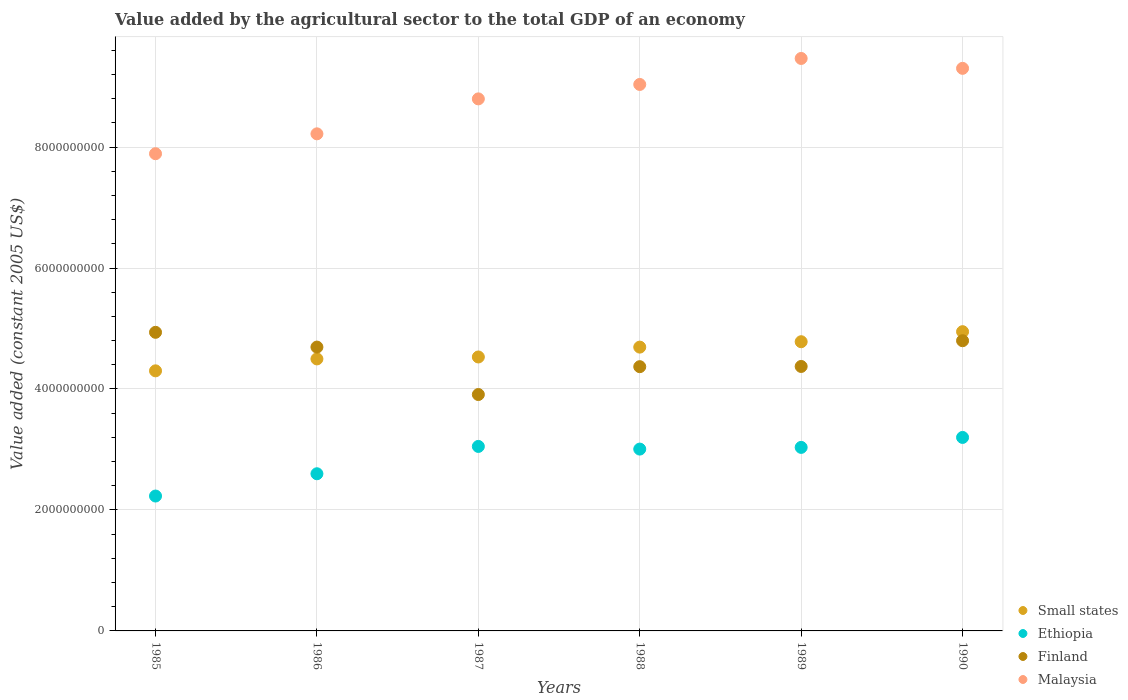How many different coloured dotlines are there?
Provide a succinct answer. 4. What is the value added by the agricultural sector in Finland in 1990?
Keep it short and to the point. 4.80e+09. Across all years, what is the maximum value added by the agricultural sector in Malaysia?
Provide a short and direct response. 9.46e+09. Across all years, what is the minimum value added by the agricultural sector in Finland?
Your answer should be very brief. 3.91e+09. In which year was the value added by the agricultural sector in Ethiopia minimum?
Offer a terse response. 1985. What is the total value added by the agricultural sector in Malaysia in the graph?
Provide a succinct answer. 5.27e+1. What is the difference between the value added by the agricultural sector in Finland in 1986 and that in 1990?
Ensure brevity in your answer.  -1.05e+08. What is the difference between the value added by the agricultural sector in Malaysia in 1986 and the value added by the agricultural sector in Small states in 1987?
Make the answer very short. 3.69e+09. What is the average value added by the agricultural sector in Malaysia per year?
Your response must be concise. 8.78e+09. In the year 1985, what is the difference between the value added by the agricultural sector in Finland and value added by the agricultural sector in Small states?
Ensure brevity in your answer.  6.37e+08. In how many years, is the value added by the agricultural sector in Malaysia greater than 800000000 US$?
Provide a succinct answer. 6. What is the ratio of the value added by the agricultural sector in Small states in 1987 to that in 1989?
Make the answer very short. 0.95. Is the difference between the value added by the agricultural sector in Finland in 1987 and 1988 greater than the difference between the value added by the agricultural sector in Small states in 1987 and 1988?
Your answer should be compact. No. What is the difference between the highest and the second highest value added by the agricultural sector in Malaysia?
Offer a terse response. 1.64e+08. What is the difference between the highest and the lowest value added by the agricultural sector in Malaysia?
Your answer should be compact. 1.57e+09. In how many years, is the value added by the agricultural sector in Finland greater than the average value added by the agricultural sector in Finland taken over all years?
Provide a succinct answer. 3. Is it the case that in every year, the sum of the value added by the agricultural sector in Small states and value added by the agricultural sector in Malaysia  is greater than the sum of value added by the agricultural sector in Finland and value added by the agricultural sector in Ethiopia?
Make the answer very short. Yes. How many years are there in the graph?
Provide a short and direct response. 6. Does the graph contain grids?
Offer a terse response. Yes. What is the title of the graph?
Your response must be concise. Value added by the agricultural sector to the total GDP of an economy. What is the label or title of the Y-axis?
Provide a short and direct response. Value added (constant 2005 US$). What is the Value added (constant 2005 US$) of Small states in 1985?
Provide a succinct answer. 4.30e+09. What is the Value added (constant 2005 US$) in Ethiopia in 1985?
Your answer should be compact. 2.23e+09. What is the Value added (constant 2005 US$) of Finland in 1985?
Ensure brevity in your answer.  4.94e+09. What is the Value added (constant 2005 US$) of Malaysia in 1985?
Offer a very short reply. 7.89e+09. What is the Value added (constant 2005 US$) of Small states in 1986?
Provide a short and direct response. 4.50e+09. What is the Value added (constant 2005 US$) in Ethiopia in 1986?
Your answer should be compact. 2.60e+09. What is the Value added (constant 2005 US$) of Finland in 1986?
Provide a short and direct response. 4.69e+09. What is the Value added (constant 2005 US$) in Malaysia in 1986?
Ensure brevity in your answer.  8.22e+09. What is the Value added (constant 2005 US$) in Small states in 1987?
Ensure brevity in your answer.  4.53e+09. What is the Value added (constant 2005 US$) in Ethiopia in 1987?
Offer a very short reply. 3.05e+09. What is the Value added (constant 2005 US$) in Finland in 1987?
Give a very brief answer. 3.91e+09. What is the Value added (constant 2005 US$) of Malaysia in 1987?
Ensure brevity in your answer.  8.80e+09. What is the Value added (constant 2005 US$) in Small states in 1988?
Keep it short and to the point. 4.69e+09. What is the Value added (constant 2005 US$) in Ethiopia in 1988?
Offer a terse response. 3.01e+09. What is the Value added (constant 2005 US$) in Finland in 1988?
Make the answer very short. 4.37e+09. What is the Value added (constant 2005 US$) of Malaysia in 1988?
Provide a succinct answer. 9.03e+09. What is the Value added (constant 2005 US$) of Small states in 1989?
Provide a short and direct response. 4.78e+09. What is the Value added (constant 2005 US$) in Ethiopia in 1989?
Your response must be concise. 3.03e+09. What is the Value added (constant 2005 US$) of Finland in 1989?
Your response must be concise. 4.37e+09. What is the Value added (constant 2005 US$) in Malaysia in 1989?
Provide a succinct answer. 9.46e+09. What is the Value added (constant 2005 US$) in Small states in 1990?
Make the answer very short. 4.95e+09. What is the Value added (constant 2005 US$) of Ethiopia in 1990?
Your answer should be very brief. 3.20e+09. What is the Value added (constant 2005 US$) in Finland in 1990?
Offer a very short reply. 4.80e+09. What is the Value added (constant 2005 US$) in Malaysia in 1990?
Give a very brief answer. 9.30e+09. Across all years, what is the maximum Value added (constant 2005 US$) of Small states?
Provide a short and direct response. 4.95e+09. Across all years, what is the maximum Value added (constant 2005 US$) in Ethiopia?
Make the answer very short. 3.20e+09. Across all years, what is the maximum Value added (constant 2005 US$) of Finland?
Your response must be concise. 4.94e+09. Across all years, what is the maximum Value added (constant 2005 US$) of Malaysia?
Offer a very short reply. 9.46e+09. Across all years, what is the minimum Value added (constant 2005 US$) in Small states?
Provide a succinct answer. 4.30e+09. Across all years, what is the minimum Value added (constant 2005 US$) in Ethiopia?
Offer a terse response. 2.23e+09. Across all years, what is the minimum Value added (constant 2005 US$) of Finland?
Ensure brevity in your answer.  3.91e+09. Across all years, what is the minimum Value added (constant 2005 US$) in Malaysia?
Your answer should be very brief. 7.89e+09. What is the total Value added (constant 2005 US$) of Small states in the graph?
Offer a very short reply. 2.77e+1. What is the total Value added (constant 2005 US$) of Ethiopia in the graph?
Keep it short and to the point. 1.71e+1. What is the total Value added (constant 2005 US$) of Finland in the graph?
Offer a very short reply. 2.71e+1. What is the total Value added (constant 2005 US$) of Malaysia in the graph?
Your response must be concise. 5.27e+1. What is the difference between the Value added (constant 2005 US$) in Small states in 1985 and that in 1986?
Give a very brief answer. -1.97e+08. What is the difference between the Value added (constant 2005 US$) in Ethiopia in 1985 and that in 1986?
Provide a succinct answer. -3.68e+08. What is the difference between the Value added (constant 2005 US$) of Finland in 1985 and that in 1986?
Provide a short and direct response. 2.44e+08. What is the difference between the Value added (constant 2005 US$) in Malaysia in 1985 and that in 1986?
Provide a short and direct response. -3.29e+08. What is the difference between the Value added (constant 2005 US$) in Small states in 1985 and that in 1987?
Give a very brief answer. -2.29e+08. What is the difference between the Value added (constant 2005 US$) in Ethiopia in 1985 and that in 1987?
Ensure brevity in your answer.  -8.20e+08. What is the difference between the Value added (constant 2005 US$) in Finland in 1985 and that in 1987?
Your response must be concise. 1.03e+09. What is the difference between the Value added (constant 2005 US$) in Malaysia in 1985 and that in 1987?
Offer a very short reply. -9.07e+08. What is the difference between the Value added (constant 2005 US$) of Small states in 1985 and that in 1988?
Provide a succinct answer. -3.92e+08. What is the difference between the Value added (constant 2005 US$) of Ethiopia in 1985 and that in 1988?
Ensure brevity in your answer.  -7.76e+08. What is the difference between the Value added (constant 2005 US$) in Finland in 1985 and that in 1988?
Ensure brevity in your answer.  5.68e+08. What is the difference between the Value added (constant 2005 US$) of Malaysia in 1985 and that in 1988?
Your response must be concise. -1.15e+09. What is the difference between the Value added (constant 2005 US$) of Small states in 1985 and that in 1989?
Your answer should be compact. -4.81e+08. What is the difference between the Value added (constant 2005 US$) in Ethiopia in 1985 and that in 1989?
Make the answer very short. -8.04e+08. What is the difference between the Value added (constant 2005 US$) of Finland in 1985 and that in 1989?
Make the answer very short. 5.64e+08. What is the difference between the Value added (constant 2005 US$) of Malaysia in 1985 and that in 1989?
Ensure brevity in your answer.  -1.57e+09. What is the difference between the Value added (constant 2005 US$) in Small states in 1985 and that in 1990?
Give a very brief answer. -6.48e+08. What is the difference between the Value added (constant 2005 US$) in Ethiopia in 1985 and that in 1990?
Keep it short and to the point. -9.69e+08. What is the difference between the Value added (constant 2005 US$) in Finland in 1985 and that in 1990?
Your response must be concise. 1.39e+08. What is the difference between the Value added (constant 2005 US$) of Malaysia in 1985 and that in 1990?
Your answer should be compact. -1.41e+09. What is the difference between the Value added (constant 2005 US$) in Small states in 1986 and that in 1987?
Offer a terse response. -3.21e+07. What is the difference between the Value added (constant 2005 US$) in Ethiopia in 1986 and that in 1987?
Offer a terse response. -4.52e+08. What is the difference between the Value added (constant 2005 US$) in Finland in 1986 and that in 1987?
Provide a succinct answer. 7.84e+08. What is the difference between the Value added (constant 2005 US$) of Malaysia in 1986 and that in 1987?
Provide a short and direct response. -5.78e+08. What is the difference between the Value added (constant 2005 US$) in Small states in 1986 and that in 1988?
Offer a terse response. -1.95e+08. What is the difference between the Value added (constant 2005 US$) in Ethiopia in 1986 and that in 1988?
Give a very brief answer. -4.08e+08. What is the difference between the Value added (constant 2005 US$) of Finland in 1986 and that in 1988?
Give a very brief answer. 3.24e+08. What is the difference between the Value added (constant 2005 US$) of Malaysia in 1986 and that in 1988?
Your response must be concise. -8.16e+08. What is the difference between the Value added (constant 2005 US$) of Small states in 1986 and that in 1989?
Keep it short and to the point. -2.84e+08. What is the difference between the Value added (constant 2005 US$) in Ethiopia in 1986 and that in 1989?
Provide a succinct answer. -4.36e+08. What is the difference between the Value added (constant 2005 US$) of Finland in 1986 and that in 1989?
Your answer should be compact. 3.20e+08. What is the difference between the Value added (constant 2005 US$) of Malaysia in 1986 and that in 1989?
Your response must be concise. -1.25e+09. What is the difference between the Value added (constant 2005 US$) in Small states in 1986 and that in 1990?
Your answer should be very brief. -4.51e+08. What is the difference between the Value added (constant 2005 US$) of Ethiopia in 1986 and that in 1990?
Offer a very short reply. -6.00e+08. What is the difference between the Value added (constant 2005 US$) in Finland in 1986 and that in 1990?
Offer a terse response. -1.05e+08. What is the difference between the Value added (constant 2005 US$) of Malaysia in 1986 and that in 1990?
Your response must be concise. -1.08e+09. What is the difference between the Value added (constant 2005 US$) in Small states in 1987 and that in 1988?
Provide a short and direct response. -1.63e+08. What is the difference between the Value added (constant 2005 US$) of Ethiopia in 1987 and that in 1988?
Your answer should be compact. 4.40e+07. What is the difference between the Value added (constant 2005 US$) of Finland in 1987 and that in 1988?
Give a very brief answer. -4.60e+08. What is the difference between the Value added (constant 2005 US$) of Malaysia in 1987 and that in 1988?
Ensure brevity in your answer.  -2.39e+08. What is the difference between the Value added (constant 2005 US$) of Small states in 1987 and that in 1989?
Provide a succinct answer. -2.52e+08. What is the difference between the Value added (constant 2005 US$) in Ethiopia in 1987 and that in 1989?
Keep it short and to the point. 1.59e+07. What is the difference between the Value added (constant 2005 US$) in Finland in 1987 and that in 1989?
Your answer should be very brief. -4.64e+08. What is the difference between the Value added (constant 2005 US$) in Malaysia in 1987 and that in 1989?
Offer a terse response. -6.68e+08. What is the difference between the Value added (constant 2005 US$) of Small states in 1987 and that in 1990?
Keep it short and to the point. -4.18e+08. What is the difference between the Value added (constant 2005 US$) of Ethiopia in 1987 and that in 1990?
Your answer should be compact. -1.49e+08. What is the difference between the Value added (constant 2005 US$) in Finland in 1987 and that in 1990?
Your answer should be compact. -8.89e+08. What is the difference between the Value added (constant 2005 US$) of Malaysia in 1987 and that in 1990?
Offer a terse response. -5.05e+08. What is the difference between the Value added (constant 2005 US$) of Small states in 1988 and that in 1989?
Your response must be concise. -8.93e+07. What is the difference between the Value added (constant 2005 US$) in Ethiopia in 1988 and that in 1989?
Make the answer very short. -2.81e+07. What is the difference between the Value added (constant 2005 US$) of Finland in 1988 and that in 1989?
Give a very brief answer. -3.63e+06. What is the difference between the Value added (constant 2005 US$) of Malaysia in 1988 and that in 1989?
Give a very brief answer. -4.30e+08. What is the difference between the Value added (constant 2005 US$) of Small states in 1988 and that in 1990?
Offer a very short reply. -2.55e+08. What is the difference between the Value added (constant 2005 US$) of Ethiopia in 1988 and that in 1990?
Keep it short and to the point. -1.93e+08. What is the difference between the Value added (constant 2005 US$) of Finland in 1988 and that in 1990?
Offer a terse response. -4.29e+08. What is the difference between the Value added (constant 2005 US$) of Malaysia in 1988 and that in 1990?
Keep it short and to the point. -2.66e+08. What is the difference between the Value added (constant 2005 US$) in Small states in 1989 and that in 1990?
Provide a succinct answer. -1.66e+08. What is the difference between the Value added (constant 2005 US$) in Ethiopia in 1989 and that in 1990?
Your response must be concise. -1.65e+08. What is the difference between the Value added (constant 2005 US$) of Finland in 1989 and that in 1990?
Ensure brevity in your answer.  -4.25e+08. What is the difference between the Value added (constant 2005 US$) in Malaysia in 1989 and that in 1990?
Ensure brevity in your answer.  1.64e+08. What is the difference between the Value added (constant 2005 US$) of Small states in 1985 and the Value added (constant 2005 US$) of Ethiopia in 1986?
Offer a very short reply. 1.70e+09. What is the difference between the Value added (constant 2005 US$) in Small states in 1985 and the Value added (constant 2005 US$) in Finland in 1986?
Ensure brevity in your answer.  -3.93e+08. What is the difference between the Value added (constant 2005 US$) in Small states in 1985 and the Value added (constant 2005 US$) in Malaysia in 1986?
Make the answer very short. -3.92e+09. What is the difference between the Value added (constant 2005 US$) in Ethiopia in 1985 and the Value added (constant 2005 US$) in Finland in 1986?
Your response must be concise. -2.46e+09. What is the difference between the Value added (constant 2005 US$) in Ethiopia in 1985 and the Value added (constant 2005 US$) in Malaysia in 1986?
Offer a very short reply. -5.99e+09. What is the difference between the Value added (constant 2005 US$) in Finland in 1985 and the Value added (constant 2005 US$) in Malaysia in 1986?
Your answer should be compact. -3.28e+09. What is the difference between the Value added (constant 2005 US$) in Small states in 1985 and the Value added (constant 2005 US$) in Ethiopia in 1987?
Provide a short and direct response. 1.25e+09. What is the difference between the Value added (constant 2005 US$) of Small states in 1985 and the Value added (constant 2005 US$) of Finland in 1987?
Give a very brief answer. 3.92e+08. What is the difference between the Value added (constant 2005 US$) of Small states in 1985 and the Value added (constant 2005 US$) of Malaysia in 1987?
Ensure brevity in your answer.  -4.50e+09. What is the difference between the Value added (constant 2005 US$) in Ethiopia in 1985 and the Value added (constant 2005 US$) in Finland in 1987?
Your answer should be very brief. -1.68e+09. What is the difference between the Value added (constant 2005 US$) of Ethiopia in 1985 and the Value added (constant 2005 US$) of Malaysia in 1987?
Keep it short and to the point. -6.57e+09. What is the difference between the Value added (constant 2005 US$) of Finland in 1985 and the Value added (constant 2005 US$) of Malaysia in 1987?
Provide a succinct answer. -3.86e+09. What is the difference between the Value added (constant 2005 US$) in Small states in 1985 and the Value added (constant 2005 US$) in Ethiopia in 1988?
Provide a short and direct response. 1.29e+09. What is the difference between the Value added (constant 2005 US$) in Small states in 1985 and the Value added (constant 2005 US$) in Finland in 1988?
Provide a succinct answer. -6.89e+07. What is the difference between the Value added (constant 2005 US$) of Small states in 1985 and the Value added (constant 2005 US$) of Malaysia in 1988?
Ensure brevity in your answer.  -4.73e+09. What is the difference between the Value added (constant 2005 US$) of Ethiopia in 1985 and the Value added (constant 2005 US$) of Finland in 1988?
Offer a very short reply. -2.14e+09. What is the difference between the Value added (constant 2005 US$) in Ethiopia in 1985 and the Value added (constant 2005 US$) in Malaysia in 1988?
Your answer should be very brief. -6.80e+09. What is the difference between the Value added (constant 2005 US$) in Finland in 1985 and the Value added (constant 2005 US$) in Malaysia in 1988?
Make the answer very short. -4.10e+09. What is the difference between the Value added (constant 2005 US$) in Small states in 1985 and the Value added (constant 2005 US$) in Ethiopia in 1989?
Offer a very short reply. 1.27e+09. What is the difference between the Value added (constant 2005 US$) of Small states in 1985 and the Value added (constant 2005 US$) of Finland in 1989?
Provide a succinct answer. -7.25e+07. What is the difference between the Value added (constant 2005 US$) in Small states in 1985 and the Value added (constant 2005 US$) in Malaysia in 1989?
Make the answer very short. -5.16e+09. What is the difference between the Value added (constant 2005 US$) of Ethiopia in 1985 and the Value added (constant 2005 US$) of Finland in 1989?
Make the answer very short. -2.14e+09. What is the difference between the Value added (constant 2005 US$) in Ethiopia in 1985 and the Value added (constant 2005 US$) in Malaysia in 1989?
Make the answer very short. -7.23e+09. What is the difference between the Value added (constant 2005 US$) of Finland in 1985 and the Value added (constant 2005 US$) of Malaysia in 1989?
Provide a short and direct response. -4.53e+09. What is the difference between the Value added (constant 2005 US$) of Small states in 1985 and the Value added (constant 2005 US$) of Ethiopia in 1990?
Your response must be concise. 1.10e+09. What is the difference between the Value added (constant 2005 US$) in Small states in 1985 and the Value added (constant 2005 US$) in Finland in 1990?
Provide a short and direct response. -4.98e+08. What is the difference between the Value added (constant 2005 US$) of Small states in 1985 and the Value added (constant 2005 US$) of Malaysia in 1990?
Offer a terse response. -5.00e+09. What is the difference between the Value added (constant 2005 US$) of Ethiopia in 1985 and the Value added (constant 2005 US$) of Finland in 1990?
Make the answer very short. -2.57e+09. What is the difference between the Value added (constant 2005 US$) of Ethiopia in 1985 and the Value added (constant 2005 US$) of Malaysia in 1990?
Provide a succinct answer. -7.07e+09. What is the difference between the Value added (constant 2005 US$) in Finland in 1985 and the Value added (constant 2005 US$) in Malaysia in 1990?
Offer a terse response. -4.36e+09. What is the difference between the Value added (constant 2005 US$) of Small states in 1986 and the Value added (constant 2005 US$) of Ethiopia in 1987?
Ensure brevity in your answer.  1.45e+09. What is the difference between the Value added (constant 2005 US$) of Small states in 1986 and the Value added (constant 2005 US$) of Finland in 1987?
Ensure brevity in your answer.  5.89e+08. What is the difference between the Value added (constant 2005 US$) in Small states in 1986 and the Value added (constant 2005 US$) in Malaysia in 1987?
Give a very brief answer. -4.30e+09. What is the difference between the Value added (constant 2005 US$) of Ethiopia in 1986 and the Value added (constant 2005 US$) of Finland in 1987?
Your answer should be compact. -1.31e+09. What is the difference between the Value added (constant 2005 US$) of Ethiopia in 1986 and the Value added (constant 2005 US$) of Malaysia in 1987?
Keep it short and to the point. -6.20e+09. What is the difference between the Value added (constant 2005 US$) in Finland in 1986 and the Value added (constant 2005 US$) in Malaysia in 1987?
Your answer should be compact. -4.10e+09. What is the difference between the Value added (constant 2005 US$) in Small states in 1986 and the Value added (constant 2005 US$) in Ethiopia in 1988?
Keep it short and to the point. 1.49e+09. What is the difference between the Value added (constant 2005 US$) of Small states in 1986 and the Value added (constant 2005 US$) of Finland in 1988?
Give a very brief answer. 1.28e+08. What is the difference between the Value added (constant 2005 US$) of Small states in 1986 and the Value added (constant 2005 US$) of Malaysia in 1988?
Ensure brevity in your answer.  -4.54e+09. What is the difference between the Value added (constant 2005 US$) of Ethiopia in 1986 and the Value added (constant 2005 US$) of Finland in 1988?
Offer a very short reply. -1.77e+09. What is the difference between the Value added (constant 2005 US$) in Ethiopia in 1986 and the Value added (constant 2005 US$) in Malaysia in 1988?
Your answer should be compact. -6.44e+09. What is the difference between the Value added (constant 2005 US$) of Finland in 1986 and the Value added (constant 2005 US$) of Malaysia in 1988?
Provide a short and direct response. -4.34e+09. What is the difference between the Value added (constant 2005 US$) of Small states in 1986 and the Value added (constant 2005 US$) of Ethiopia in 1989?
Provide a short and direct response. 1.46e+09. What is the difference between the Value added (constant 2005 US$) of Small states in 1986 and the Value added (constant 2005 US$) of Finland in 1989?
Provide a short and direct response. 1.25e+08. What is the difference between the Value added (constant 2005 US$) of Small states in 1986 and the Value added (constant 2005 US$) of Malaysia in 1989?
Provide a short and direct response. -4.97e+09. What is the difference between the Value added (constant 2005 US$) of Ethiopia in 1986 and the Value added (constant 2005 US$) of Finland in 1989?
Your answer should be very brief. -1.77e+09. What is the difference between the Value added (constant 2005 US$) in Ethiopia in 1986 and the Value added (constant 2005 US$) in Malaysia in 1989?
Give a very brief answer. -6.87e+09. What is the difference between the Value added (constant 2005 US$) of Finland in 1986 and the Value added (constant 2005 US$) of Malaysia in 1989?
Provide a short and direct response. -4.77e+09. What is the difference between the Value added (constant 2005 US$) of Small states in 1986 and the Value added (constant 2005 US$) of Ethiopia in 1990?
Offer a very short reply. 1.30e+09. What is the difference between the Value added (constant 2005 US$) of Small states in 1986 and the Value added (constant 2005 US$) of Finland in 1990?
Provide a short and direct response. -3.01e+08. What is the difference between the Value added (constant 2005 US$) in Small states in 1986 and the Value added (constant 2005 US$) in Malaysia in 1990?
Ensure brevity in your answer.  -4.80e+09. What is the difference between the Value added (constant 2005 US$) in Ethiopia in 1986 and the Value added (constant 2005 US$) in Finland in 1990?
Provide a short and direct response. -2.20e+09. What is the difference between the Value added (constant 2005 US$) of Ethiopia in 1986 and the Value added (constant 2005 US$) of Malaysia in 1990?
Provide a short and direct response. -6.70e+09. What is the difference between the Value added (constant 2005 US$) in Finland in 1986 and the Value added (constant 2005 US$) in Malaysia in 1990?
Your answer should be very brief. -4.61e+09. What is the difference between the Value added (constant 2005 US$) in Small states in 1987 and the Value added (constant 2005 US$) in Ethiopia in 1988?
Offer a terse response. 1.52e+09. What is the difference between the Value added (constant 2005 US$) in Small states in 1987 and the Value added (constant 2005 US$) in Finland in 1988?
Give a very brief answer. 1.60e+08. What is the difference between the Value added (constant 2005 US$) in Small states in 1987 and the Value added (constant 2005 US$) in Malaysia in 1988?
Offer a very short reply. -4.51e+09. What is the difference between the Value added (constant 2005 US$) of Ethiopia in 1987 and the Value added (constant 2005 US$) of Finland in 1988?
Ensure brevity in your answer.  -1.32e+09. What is the difference between the Value added (constant 2005 US$) of Ethiopia in 1987 and the Value added (constant 2005 US$) of Malaysia in 1988?
Keep it short and to the point. -5.98e+09. What is the difference between the Value added (constant 2005 US$) of Finland in 1987 and the Value added (constant 2005 US$) of Malaysia in 1988?
Provide a short and direct response. -5.13e+09. What is the difference between the Value added (constant 2005 US$) of Small states in 1987 and the Value added (constant 2005 US$) of Ethiopia in 1989?
Provide a succinct answer. 1.49e+09. What is the difference between the Value added (constant 2005 US$) of Small states in 1987 and the Value added (constant 2005 US$) of Finland in 1989?
Give a very brief answer. 1.57e+08. What is the difference between the Value added (constant 2005 US$) of Small states in 1987 and the Value added (constant 2005 US$) of Malaysia in 1989?
Keep it short and to the point. -4.94e+09. What is the difference between the Value added (constant 2005 US$) in Ethiopia in 1987 and the Value added (constant 2005 US$) in Finland in 1989?
Offer a very short reply. -1.32e+09. What is the difference between the Value added (constant 2005 US$) in Ethiopia in 1987 and the Value added (constant 2005 US$) in Malaysia in 1989?
Your answer should be compact. -6.41e+09. What is the difference between the Value added (constant 2005 US$) of Finland in 1987 and the Value added (constant 2005 US$) of Malaysia in 1989?
Make the answer very short. -5.56e+09. What is the difference between the Value added (constant 2005 US$) in Small states in 1987 and the Value added (constant 2005 US$) in Ethiopia in 1990?
Offer a terse response. 1.33e+09. What is the difference between the Value added (constant 2005 US$) in Small states in 1987 and the Value added (constant 2005 US$) in Finland in 1990?
Make the answer very short. -2.69e+08. What is the difference between the Value added (constant 2005 US$) in Small states in 1987 and the Value added (constant 2005 US$) in Malaysia in 1990?
Offer a terse response. -4.77e+09. What is the difference between the Value added (constant 2005 US$) in Ethiopia in 1987 and the Value added (constant 2005 US$) in Finland in 1990?
Offer a very short reply. -1.75e+09. What is the difference between the Value added (constant 2005 US$) of Ethiopia in 1987 and the Value added (constant 2005 US$) of Malaysia in 1990?
Your answer should be compact. -6.25e+09. What is the difference between the Value added (constant 2005 US$) of Finland in 1987 and the Value added (constant 2005 US$) of Malaysia in 1990?
Ensure brevity in your answer.  -5.39e+09. What is the difference between the Value added (constant 2005 US$) in Small states in 1988 and the Value added (constant 2005 US$) in Ethiopia in 1989?
Your answer should be compact. 1.66e+09. What is the difference between the Value added (constant 2005 US$) in Small states in 1988 and the Value added (constant 2005 US$) in Finland in 1989?
Your answer should be very brief. 3.20e+08. What is the difference between the Value added (constant 2005 US$) in Small states in 1988 and the Value added (constant 2005 US$) in Malaysia in 1989?
Give a very brief answer. -4.77e+09. What is the difference between the Value added (constant 2005 US$) in Ethiopia in 1988 and the Value added (constant 2005 US$) in Finland in 1989?
Keep it short and to the point. -1.37e+09. What is the difference between the Value added (constant 2005 US$) in Ethiopia in 1988 and the Value added (constant 2005 US$) in Malaysia in 1989?
Keep it short and to the point. -6.46e+09. What is the difference between the Value added (constant 2005 US$) in Finland in 1988 and the Value added (constant 2005 US$) in Malaysia in 1989?
Keep it short and to the point. -5.10e+09. What is the difference between the Value added (constant 2005 US$) in Small states in 1988 and the Value added (constant 2005 US$) in Ethiopia in 1990?
Your answer should be very brief. 1.49e+09. What is the difference between the Value added (constant 2005 US$) of Small states in 1988 and the Value added (constant 2005 US$) of Finland in 1990?
Your answer should be compact. -1.06e+08. What is the difference between the Value added (constant 2005 US$) of Small states in 1988 and the Value added (constant 2005 US$) of Malaysia in 1990?
Your answer should be compact. -4.61e+09. What is the difference between the Value added (constant 2005 US$) in Ethiopia in 1988 and the Value added (constant 2005 US$) in Finland in 1990?
Give a very brief answer. -1.79e+09. What is the difference between the Value added (constant 2005 US$) in Ethiopia in 1988 and the Value added (constant 2005 US$) in Malaysia in 1990?
Ensure brevity in your answer.  -6.29e+09. What is the difference between the Value added (constant 2005 US$) in Finland in 1988 and the Value added (constant 2005 US$) in Malaysia in 1990?
Offer a very short reply. -4.93e+09. What is the difference between the Value added (constant 2005 US$) in Small states in 1989 and the Value added (constant 2005 US$) in Ethiopia in 1990?
Offer a terse response. 1.58e+09. What is the difference between the Value added (constant 2005 US$) in Small states in 1989 and the Value added (constant 2005 US$) in Finland in 1990?
Make the answer very short. -1.65e+07. What is the difference between the Value added (constant 2005 US$) in Small states in 1989 and the Value added (constant 2005 US$) in Malaysia in 1990?
Ensure brevity in your answer.  -4.52e+09. What is the difference between the Value added (constant 2005 US$) in Ethiopia in 1989 and the Value added (constant 2005 US$) in Finland in 1990?
Give a very brief answer. -1.76e+09. What is the difference between the Value added (constant 2005 US$) in Ethiopia in 1989 and the Value added (constant 2005 US$) in Malaysia in 1990?
Offer a very short reply. -6.27e+09. What is the difference between the Value added (constant 2005 US$) in Finland in 1989 and the Value added (constant 2005 US$) in Malaysia in 1990?
Provide a short and direct response. -4.93e+09. What is the average Value added (constant 2005 US$) in Small states per year?
Your answer should be compact. 4.62e+09. What is the average Value added (constant 2005 US$) of Ethiopia per year?
Keep it short and to the point. 2.85e+09. What is the average Value added (constant 2005 US$) in Finland per year?
Provide a succinct answer. 4.51e+09. What is the average Value added (constant 2005 US$) in Malaysia per year?
Provide a succinct answer. 8.78e+09. In the year 1985, what is the difference between the Value added (constant 2005 US$) in Small states and Value added (constant 2005 US$) in Ethiopia?
Keep it short and to the point. 2.07e+09. In the year 1985, what is the difference between the Value added (constant 2005 US$) of Small states and Value added (constant 2005 US$) of Finland?
Give a very brief answer. -6.37e+08. In the year 1985, what is the difference between the Value added (constant 2005 US$) of Small states and Value added (constant 2005 US$) of Malaysia?
Your response must be concise. -3.59e+09. In the year 1985, what is the difference between the Value added (constant 2005 US$) of Ethiopia and Value added (constant 2005 US$) of Finland?
Ensure brevity in your answer.  -2.71e+09. In the year 1985, what is the difference between the Value added (constant 2005 US$) of Ethiopia and Value added (constant 2005 US$) of Malaysia?
Your answer should be compact. -5.66e+09. In the year 1985, what is the difference between the Value added (constant 2005 US$) of Finland and Value added (constant 2005 US$) of Malaysia?
Your answer should be compact. -2.95e+09. In the year 1986, what is the difference between the Value added (constant 2005 US$) of Small states and Value added (constant 2005 US$) of Ethiopia?
Provide a succinct answer. 1.90e+09. In the year 1986, what is the difference between the Value added (constant 2005 US$) of Small states and Value added (constant 2005 US$) of Finland?
Provide a short and direct response. -1.96e+08. In the year 1986, what is the difference between the Value added (constant 2005 US$) of Small states and Value added (constant 2005 US$) of Malaysia?
Your answer should be compact. -3.72e+09. In the year 1986, what is the difference between the Value added (constant 2005 US$) in Ethiopia and Value added (constant 2005 US$) in Finland?
Offer a terse response. -2.09e+09. In the year 1986, what is the difference between the Value added (constant 2005 US$) in Ethiopia and Value added (constant 2005 US$) in Malaysia?
Keep it short and to the point. -5.62e+09. In the year 1986, what is the difference between the Value added (constant 2005 US$) in Finland and Value added (constant 2005 US$) in Malaysia?
Provide a short and direct response. -3.53e+09. In the year 1987, what is the difference between the Value added (constant 2005 US$) in Small states and Value added (constant 2005 US$) in Ethiopia?
Ensure brevity in your answer.  1.48e+09. In the year 1987, what is the difference between the Value added (constant 2005 US$) in Small states and Value added (constant 2005 US$) in Finland?
Your response must be concise. 6.21e+08. In the year 1987, what is the difference between the Value added (constant 2005 US$) in Small states and Value added (constant 2005 US$) in Malaysia?
Offer a very short reply. -4.27e+09. In the year 1987, what is the difference between the Value added (constant 2005 US$) in Ethiopia and Value added (constant 2005 US$) in Finland?
Give a very brief answer. -8.58e+08. In the year 1987, what is the difference between the Value added (constant 2005 US$) in Ethiopia and Value added (constant 2005 US$) in Malaysia?
Your answer should be very brief. -5.75e+09. In the year 1987, what is the difference between the Value added (constant 2005 US$) in Finland and Value added (constant 2005 US$) in Malaysia?
Give a very brief answer. -4.89e+09. In the year 1988, what is the difference between the Value added (constant 2005 US$) in Small states and Value added (constant 2005 US$) in Ethiopia?
Your answer should be very brief. 1.69e+09. In the year 1988, what is the difference between the Value added (constant 2005 US$) of Small states and Value added (constant 2005 US$) of Finland?
Provide a short and direct response. 3.23e+08. In the year 1988, what is the difference between the Value added (constant 2005 US$) in Small states and Value added (constant 2005 US$) in Malaysia?
Your response must be concise. -4.34e+09. In the year 1988, what is the difference between the Value added (constant 2005 US$) in Ethiopia and Value added (constant 2005 US$) in Finland?
Your response must be concise. -1.36e+09. In the year 1988, what is the difference between the Value added (constant 2005 US$) in Ethiopia and Value added (constant 2005 US$) in Malaysia?
Ensure brevity in your answer.  -6.03e+09. In the year 1988, what is the difference between the Value added (constant 2005 US$) of Finland and Value added (constant 2005 US$) of Malaysia?
Provide a short and direct response. -4.67e+09. In the year 1989, what is the difference between the Value added (constant 2005 US$) in Small states and Value added (constant 2005 US$) in Ethiopia?
Offer a very short reply. 1.75e+09. In the year 1989, what is the difference between the Value added (constant 2005 US$) in Small states and Value added (constant 2005 US$) in Finland?
Ensure brevity in your answer.  4.09e+08. In the year 1989, what is the difference between the Value added (constant 2005 US$) in Small states and Value added (constant 2005 US$) in Malaysia?
Your answer should be very brief. -4.68e+09. In the year 1989, what is the difference between the Value added (constant 2005 US$) of Ethiopia and Value added (constant 2005 US$) of Finland?
Provide a succinct answer. -1.34e+09. In the year 1989, what is the difference between the Value added (constant 2005 US$) in Ethiopia and Value added (constant 2005 US$) in Malaysia?
Ensure brevity in your answer.  -6.43e+09. In the year 1989, what is the difference between the Value added (constant 2005 US$) in Finland and Value added (constant 2005 US$) in Malaysia?
Your answer should be very brief. -5.09e+09. In the year 1990, what is the difference between the Value added (constant 2005 US$) of Small states and Value added (constant 2005 US$) of Ethiopia?
Ensure brevity in your answer.  1.75e+09. In the year 1990, what is the difference between the Value added (constant 2005 US$) in Small states and Value added (constant 2005 US$) in Finland?
Give a very brief answer. 1.50e+08. In the year 1990, what is the difference between the Value added (constant 2005 US$) in Small states and Value added (constant 2005 US$) in Malaysia?
Offer a very short reply. -4.35e+09. In the year 1990, what is the difference between the Value added (constant 2005 US$) in Ethiopia and Value added (constant 2005 US$) in Finland?
Offer a very short reply. -1.60e+09. In the year 1990, what is the difference between the Value added (constant 2005 US$) in Ethiopia and Value added (constant 2005 US$) in Malaysia?
Offer a very short reply. -6.10e+09. In the year 1990, what is the difference between the Value added (constant 2005 US$) in Finland and Value added (constant 2005 US$) in Malaysia?
Offer a terse response. -4.50e+09. What is the ratio of the Value added (constant 2005 US$) in Small states in 1985 to that in 1986?
Ensure brevity in your answer.  0.96. What is the ratio of the Value added (constant 2005 US$) of Ethiopia in 1985 to that in 1986?
Make the answer very short. 0.86. What is the ratio of the Value added (constant 2005 US$) in Finland in 1985 to that in 1986?
Make the answer very short. 1.05. What is the ratio of the Value added (constant 2005 US$) of Malaysia in 1985 to that in 1986?
Provide a succinct answer. 0.96. What is the ratio of the Value added (constant 2005 US$) of Small states in 1985 to that in 1987?
Your answer should be very brief. 0.95. What is the ratio of the Value added (constant 2005 US$) of Ethiopia in 1985 to that in 1987?
Your response must be concise. 0.73. What is the ratio of the Value added (constant 2005 US$) in Finland in 1985 to that in 1987?
Ensure brevity in your answer.  1.26. What is the ratio of the Value added (constant 2005 US$) of Malaysia in 1985 to that in 1987?
Make the answer very short. 0.9. What is the ratio of the Value added (constant 2005 US$) in Small states in 1985 to that in 1988?
Offer a very short reply. 0.92. What is the ratio of the Value added (constant 2005 US$) in Ethiopia in 1985 to that in 1988?
Offer a very short reply. 0.74. What is the ratio of the Value added (constant 2005 US$) in Finland in 1985 to that in 1988?
Keep it short and to the point. 1.13. What is the ratio of the Value added (constant 2005 US$) of Malaysia in 1985 to that in 1988?
Ensure brevity in your answer.  0.87. What is the ratio of the Value added (constant 2005 US$) of Small states in 1985 to that in 1989?
Your answer should be very brief. 0.9. What is the ratio of the Value added (constant 2005 US$) in Ethiopia in 1985 to that in 1989?
Provide a short and direct response. 0.73. What is the ratio of the Value added (constant 2005 US$) in Finland in 1985 to that in 1989?
Provide a short and direct response. 1.13. What is the ratio of the Value added (constant 2005 US$) in Malaysia in 1985 to that in 1989?
Offer a very short reply. 0.83. What is the ratio of the Value added (constant 2005 US$) of Small states in 1985 to that in 1990?
Make the answer very short. 0.87. What is the ratio of the Value added (constant 2005 US$) of Ethiopia in 1985 to that in 1990?
Offer a terse response. 0.7. What is the ratio of the Value added (constant 2005 US$) of Malaysia in 1985 to that in 1990?
Ensure brevity in your answer.  0.85. What is the ratio of the Value added (constant 2005 US$) of Ethiopia in 1986 to that in 1987?
Your response must be concise. 0.85. What is the ratio of the Value added (constant 2005 US$) of Finland in 1986 to that in 1987?
Offer a terse response. 1.2. What is the ratio of the Value added (constant 2005 US$) of Malaysia in 1986 to that in 1987?
Ensure brevity in your answer.  0.93. What is the ratio of the Value added (constant 2005 US$) in Small states in 1986 to that in 1988?
Provide a succinct answer. 0.96. What is the ratio of the Value added (constant 2005 US$) of Ethiopia in 1986 to that in 1988?
Give a very brief answer. 0.86. What is the ratio of the Value added (constant 2005 US$) in Finland in 1986 to that in 1988?
Provide a succinct answer. 1.07. What is the ratio of the Value added (constant 2005 US$) of Malaysia in 1986 to that in 1988?
Keep it short and to the point. 0.91. What is the ratio of the Value added (constant 2005 US$) of Small states in 1986 to that in 1989?
Give a very brief answer. 0.94. What is the ratio of the Value added (constant 2005 US$) of Ethiopia in 1986 to that in 1989?
Give a very brief answer. 0.86. What is the ratio of the Value added (constant 2005 US$) of Finland in 1986 to that in 1989?
Offer a very short reply. 1.07. What is the ratio of the Value added (constant 2005 US$) of Malaysia in 1986 to that in 1989?
Offer a terse response. 0.87. What is the ratio of the Value added (constant 2005 US$) of Small states in 1986 to that in 1990?
Offer a terse response. 0.91. What is the ratio of the Value added (constant 2005 US$) of Ethiopia in 1986 to that in 1990?
Provide a short and direct response. 0.81. What is the ratio of the Value added (constant 2005 US$) of Finland in 1986 to that in 1990?
Make the answer very short. 0.98. What is the ratio of the Value added (constant 2005 US$) in Malaysia in 1986 to that in 1990?
Offer a terse response. 0.88. What is the ratio of the Value added (constant 2005 US$) of Small states in 1987 to that in 1988?
Your answer should be compact. 0.97. What is the ratio of the Value added (constant 2005 US$) in Ethiopia in 1987 to that in 1988?
Your answer should be very brief. 1.01. What is the ratio of the Value added (constant 2005 US$) of Finland in 1987 to that in 1988?
Keep it short and to the point. 0.89. What is the ratio of the Value added (constant 2005 US$) of Malaysia in 1987 to that in 1988?
Make the answer very short. 0.97. What is the ratio of the Value added (constant 2005 US$) of Small states in 1987 to that in 1989?
Your response must be concise. 0.95. What is the ratio of the Value added (constant 2005 US$) in Ethiopia in 1987 to that in 1989?
Give a very brief answer. 1.01. What is the ratio of the Value added (constant 2005 US$) of Finland in 1987 to that in 1989?
Ensure brevity in your answer.  0.89. What is the ratio of the Value added (constant 2005 US$) of Malaysia in 1987 to that in 1989?
Provide a short and direct response. 0.93. What is the ratio of the Value added (constant 2005 US$) of Small states in 1987 to that in 1990?
Keep it short and to the point. 0.92. What is the ratio of the Value added (constant 2005 US$) of Ethiopia in 1987 to that in 1990?
Keep it short and to the point. 0.95. What is the ratio of the Value added (constant 2005 US$) in Finland in 1987 to that in 1990?
Provide a succinct answer. 0.81. What is the ratio of the Value added (constant 2005 US$) of Malaysia in 1987 to that in 1990?
Provide a succinct answer. 0.95. What is the ratio of the Value added (constant 2005 US$) of Small states in 1988 to that in 1989?
Your answer should be compact. 0.98. What is the ratio of the Value added (constant 2005 US$) of Ethiopia in 1988 to that in 1989?
Provide a succinct answer. 0.99. What is the ratio of the Value added (constant 2005 US$) of Finland in 1988 to that in 1989?
Your answer should be very brief. 1. What is the ratio of the Value added (constant 2005 US$) of Malaysia in 1988 to that in 1989?
Provide a short and direct response. 0.95. What is the ratio of the Value added (constant 2005 US$) of Small states in 1988 to that in 1990?
Keep it short and to the point. 0.95. What is the ratio of the Value added (constant 2005 US$) of Ethiopia in 1988 to that in 1990?
Make the answer very short. 0.94. What is the ratio of the Value added (constant 2005 US$) in Finland in 1988 to that in 1990?
Provide a succinct answer. 0.91. What is the ratio of the Value added (constant 2005 US$) of Malaysia in 1988 to that in 1990?
Keep it short and to the point. 0.97. What is the ratio of the Value added (constant 2005 US$) in Small states in 1989 to that in 1990?
Provide a short and direct response. 0.97. What is the ratio of the Value added (constant 2005 US$) in Ethiopia in 1989 to that in 1990?
Offer a terse response. 0.95. What is the ratio of the Value added (constant 2005 US$) of Finland in 1989 to that in 1990?
Keep it short and to the point. 0.91. What is the ratio of the Value added (constant 2005 US$) of Malaysia in 1989 to that in 1990?
Your response must be concise. 1.02. What is the difference between the highest and the second highest Value added (constant 2005 US$) of Small states?
Offer a terse response. 1.66e+08. What is the difference between the highest and the second highest Value added (constant 2005 US$) of Ethiopia?
Your answer should be very brief. 1.49e+08. What is the difference between the highest and the second highest Value added (constant 2005 US$) of Finland?
Offer a very short reply. 1.39e+08. What is the difference between the highest and the second highest Value added (constant 2005 US$) of Malaysia?
Your response must be concise. 1.64e+08. What is the difference between the highest and the lowest Value added (constant 2005 US$) of Small states?
Your answer should be very brief. 6.48e+08. What is the difference between the highest and the lowest Value added (constant 2005 US$) in Ethiopia?
Provide a succinct answer. 9.69e+08. What is the difference between the highest and the lowest Value added (constant 2005 US$) of Finland?
Your answer should be compact. 1.03e+09. What is the difference between the highest and the lowest Value added (constant 2005 US$) in Malaysia?
Your answer should be very brief. 1.57e+09. 